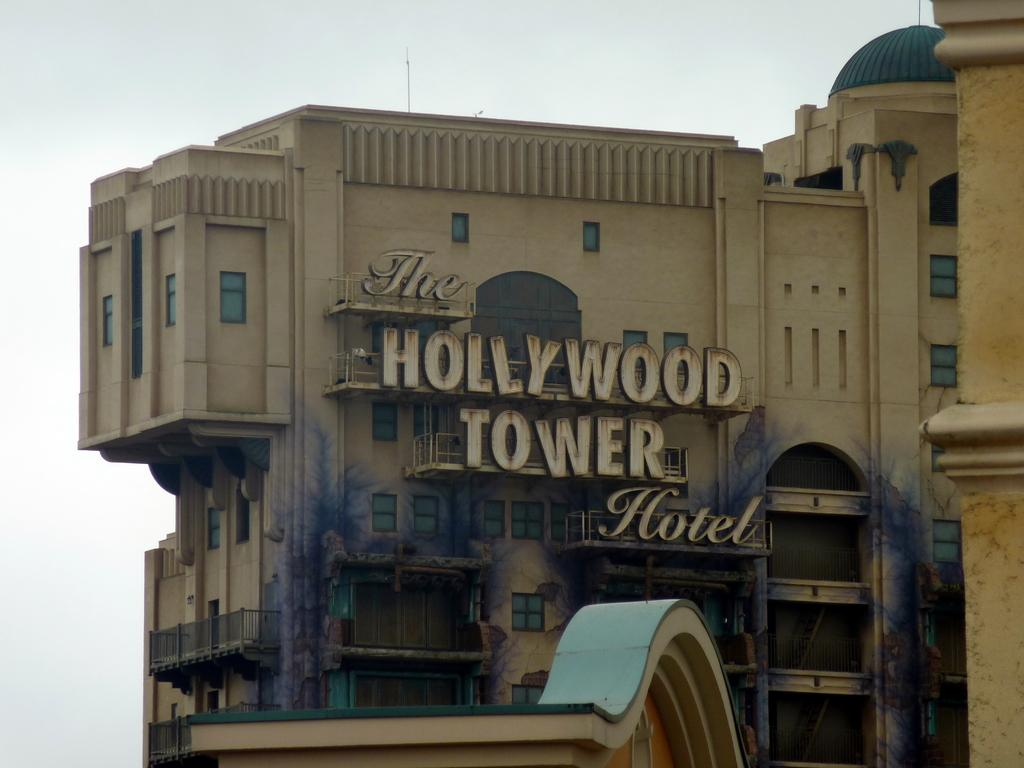<image>
Provide a brief description of the given image. The Hollywood tower hotel letters are a mix of cursive and print. 